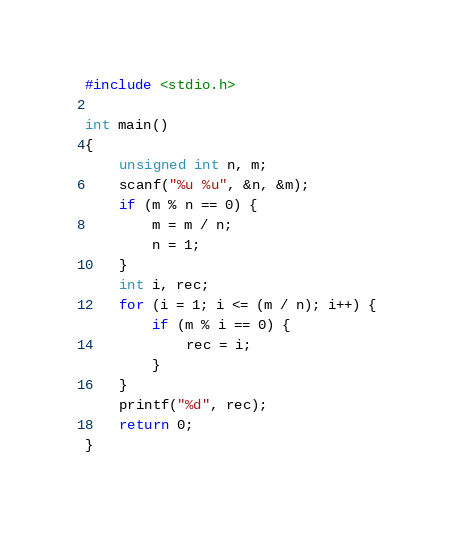<code> <loc_0><loc_0><loc_500><loc_500><_C_>#include <stdio.h>

int main()
{
    unsigned int n, m;
    scanf("%u %u", &n, &m);
    if (m % n == 0) {
        m = m / n;
        n = 1;
    }
    int i, rec;
    for (i = 1; i <= (m / n); i++) {
        if (m % i == 0) {
            rec = i;
        }
    }
    printf("%d", rec);
    return 0;
}
</code> 